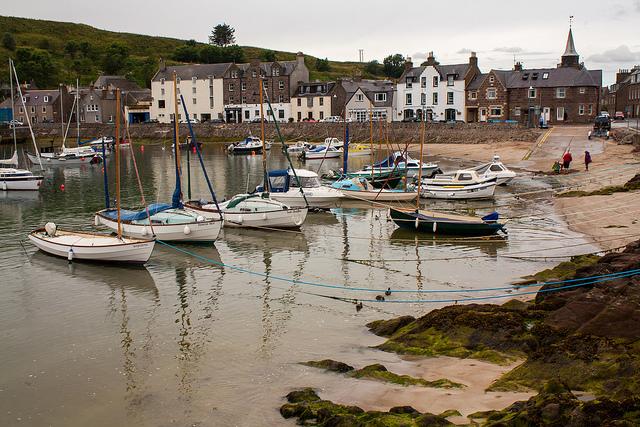What is in the background?
Give a very brief answer. Buildings. How many boats re blue?
Be succinct. 1. What color is the water?
Short answer required. Brown. How many people are there?
Be succinct. 2. What is the weather like?
Concise answer only. Cloudy. Do any of the boats have visible oars?
Concise answer only. No. 